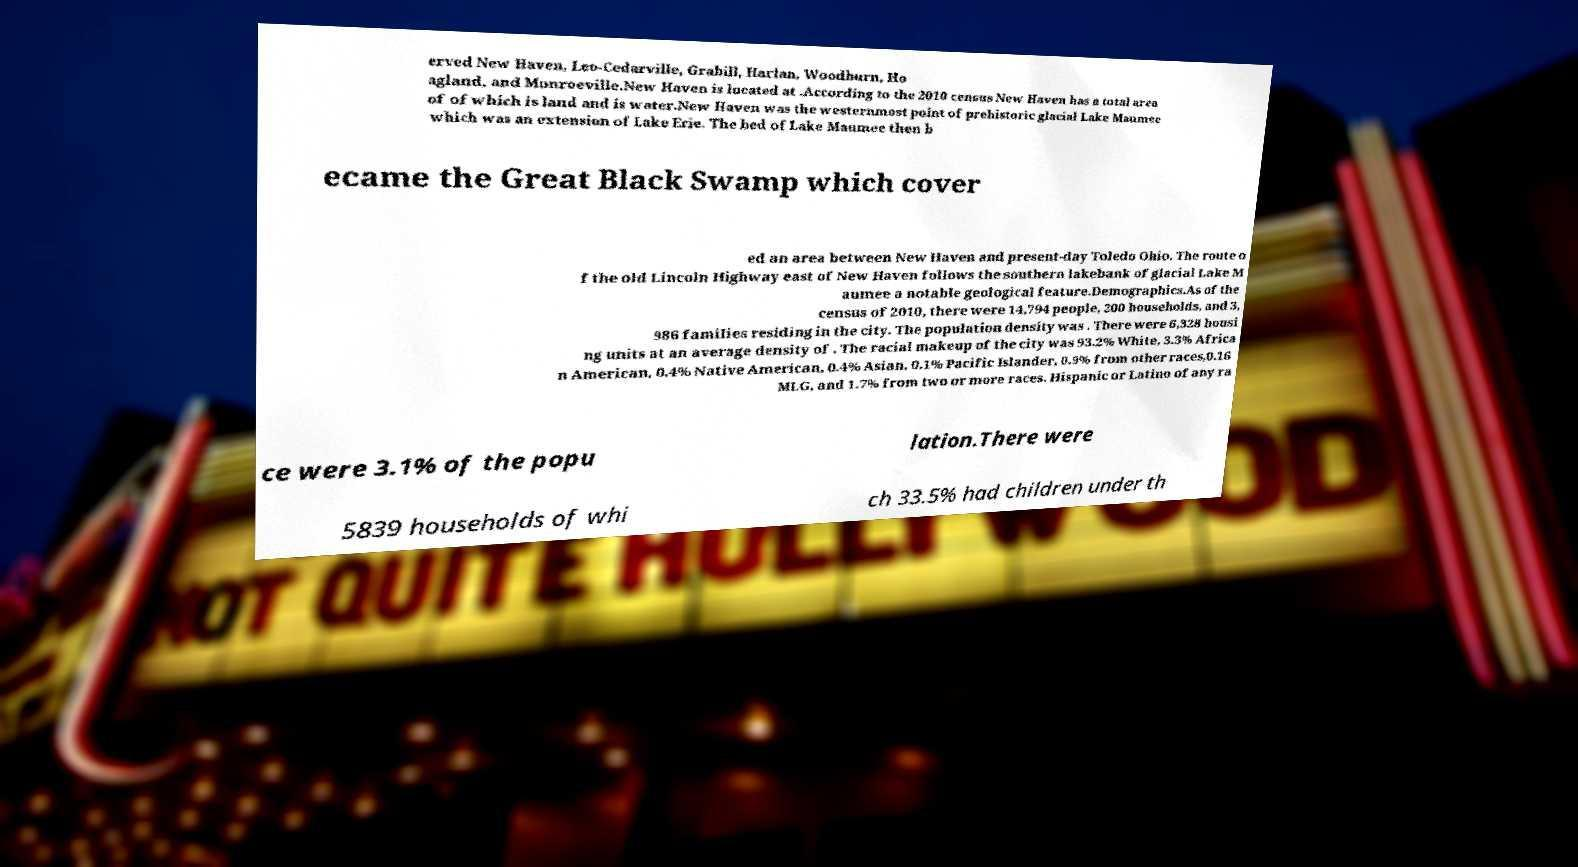For documentation purposes, I need the text within this image transcribed. Could you provide that? erved New Haven, Leo-Cedarville, Grabill, Harlan, Woodburn, Ho agland, and Monroeville.New Haven is located at .According to the 2010 census New Haven has a total area of of which is land and is water.New Haven was the westernmost point of prehistoric glacial Lake Maumee which was an extension of Lake Erie. The bed of Lake Maumee then b ecame the Great Black Swamp which cover ed an area between New Haven and present-day Toledo Ohio. The route o f the old Lincoln Highway east of New Haven follows the southern lakebank of glacial Lake M aumee a notable geological feature.Demographics.As of the census of 2010, there were 14,794 people, 200 households, and 3, 986 families residing in the city. The population density was . There were 6,328 housi ng units at an average density of . The racial makeup of the city was 93.2% White, 3.3% Africa n American, 0.4% Native American, 0.4% Asian, 0.1% Pacific Islander, 0.9% from other races,0.16 MLG, and 1.7% from two or more races. Hispanic or Latino of any ra ce were 3.1% of the popu lation.There were 5839 households of whi ch 33.5% had children under th 